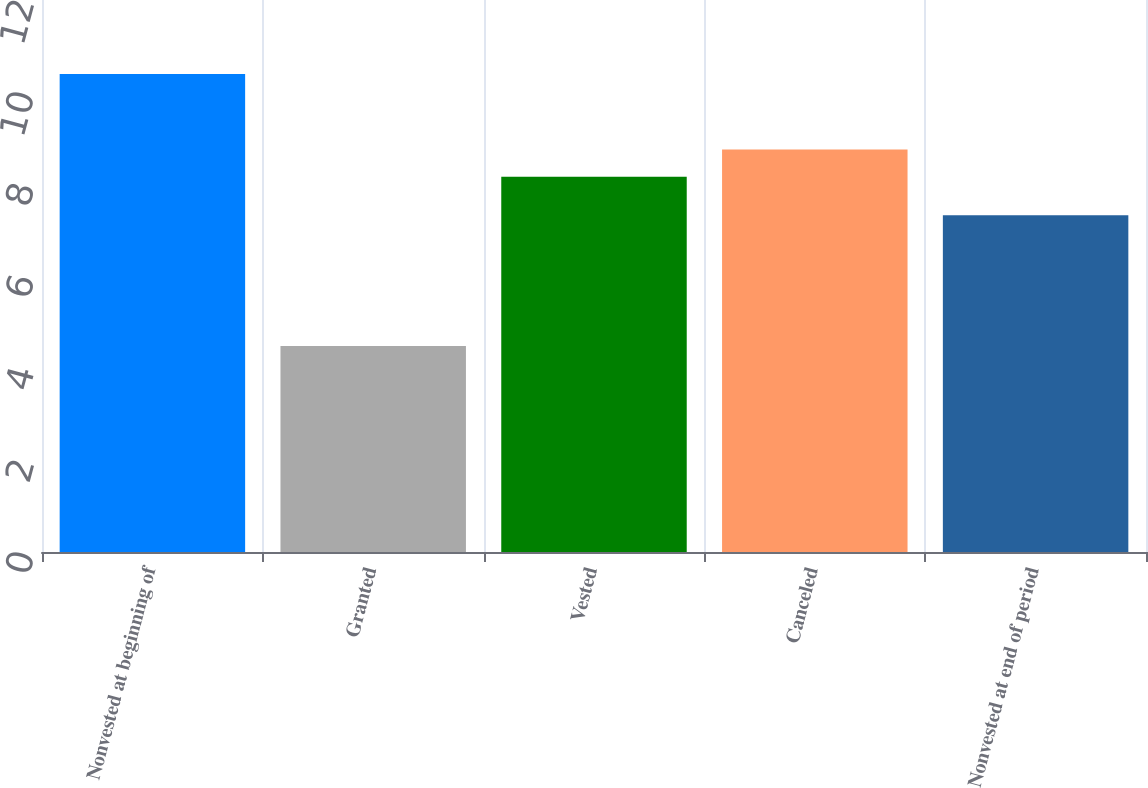Convert chart to OTSL. <chart><loc_0><loc_0><loc_500><loc_500><bar_chart><fcel>Nonvested at beginning of<fcel>Granted<fcel>Vested<fcel>Canceled<fcel>Nonvested at end of period<nl><fcel>10.39<fcel>4.48<fcel>8.16<fcel>8.75<fcel>7.32<nl></chart> 